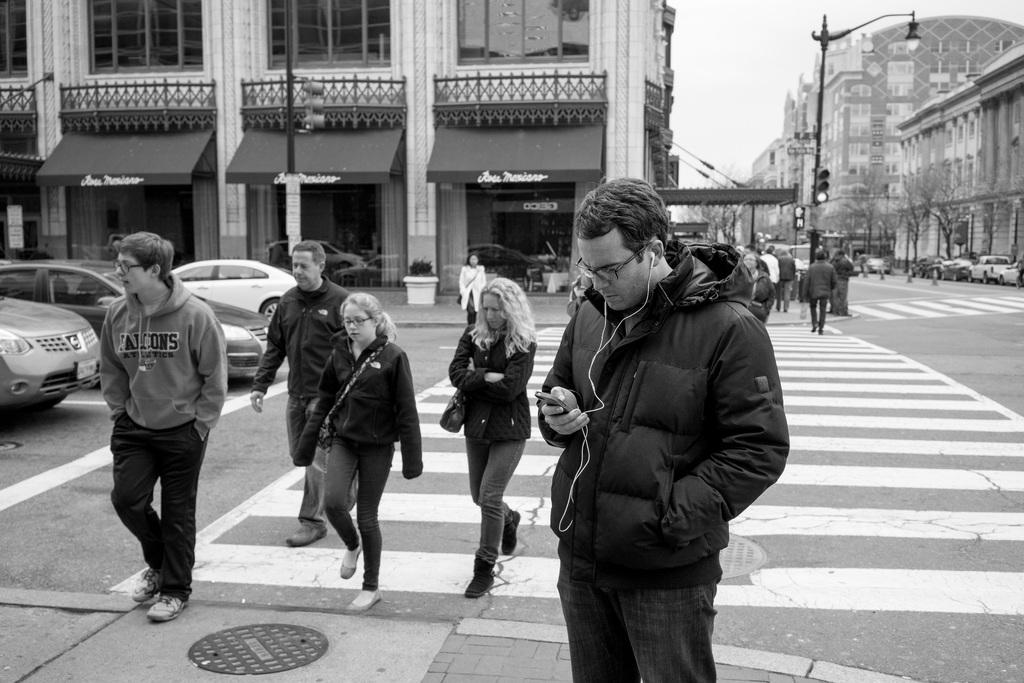What are the people in the image doing? There are persons walking on the road in the image. What else can be seen in the image besides the people? There are vehicles and buildings visible in the image. What type of skate is being used by the person in the image? There is no skate present in the image; the people are walking on the road. What is the color of the neck of the person in the image? There is no specific person identified in the image, and even if there were, the color of their neck cannot be determined from the image. 